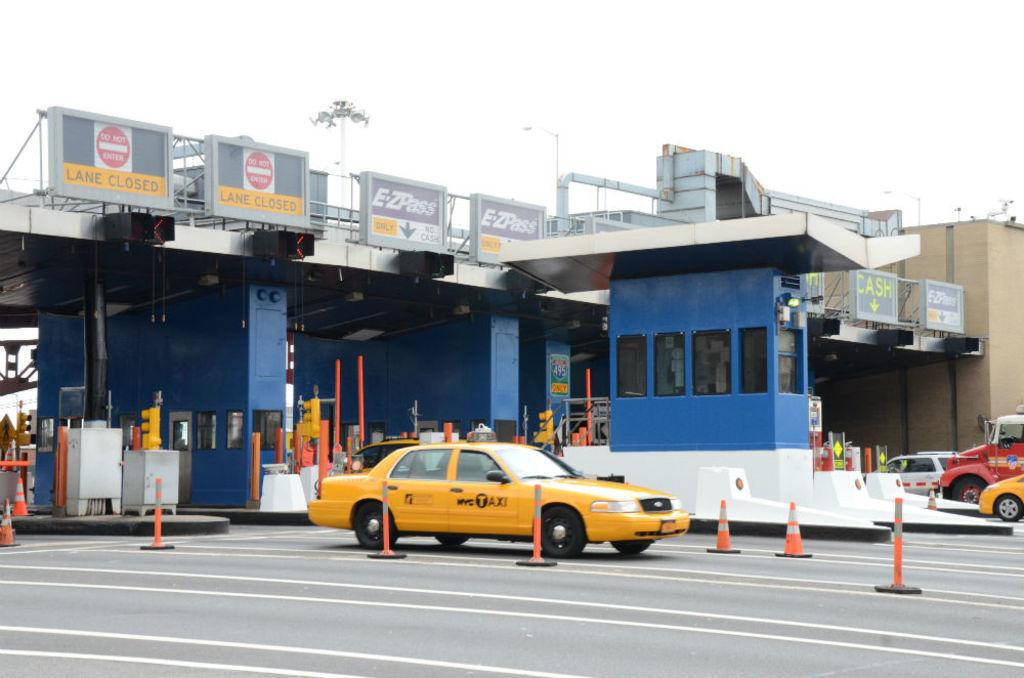<image>
Render a clear and concise summary of the photo. a taxi passing through a toll booth in the E-ZPass lane 